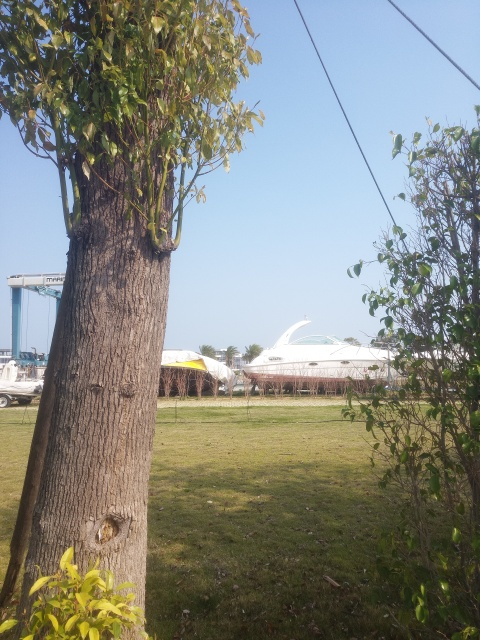How are the details and texture of the yacht in the distance presented? The details and texture of the yacht in the distance are somewhat blurred due to the focus on the foreground in the image. This results in the yacht lacking crispness and clearly observable textures, typically visible in closer or more focused shots. 